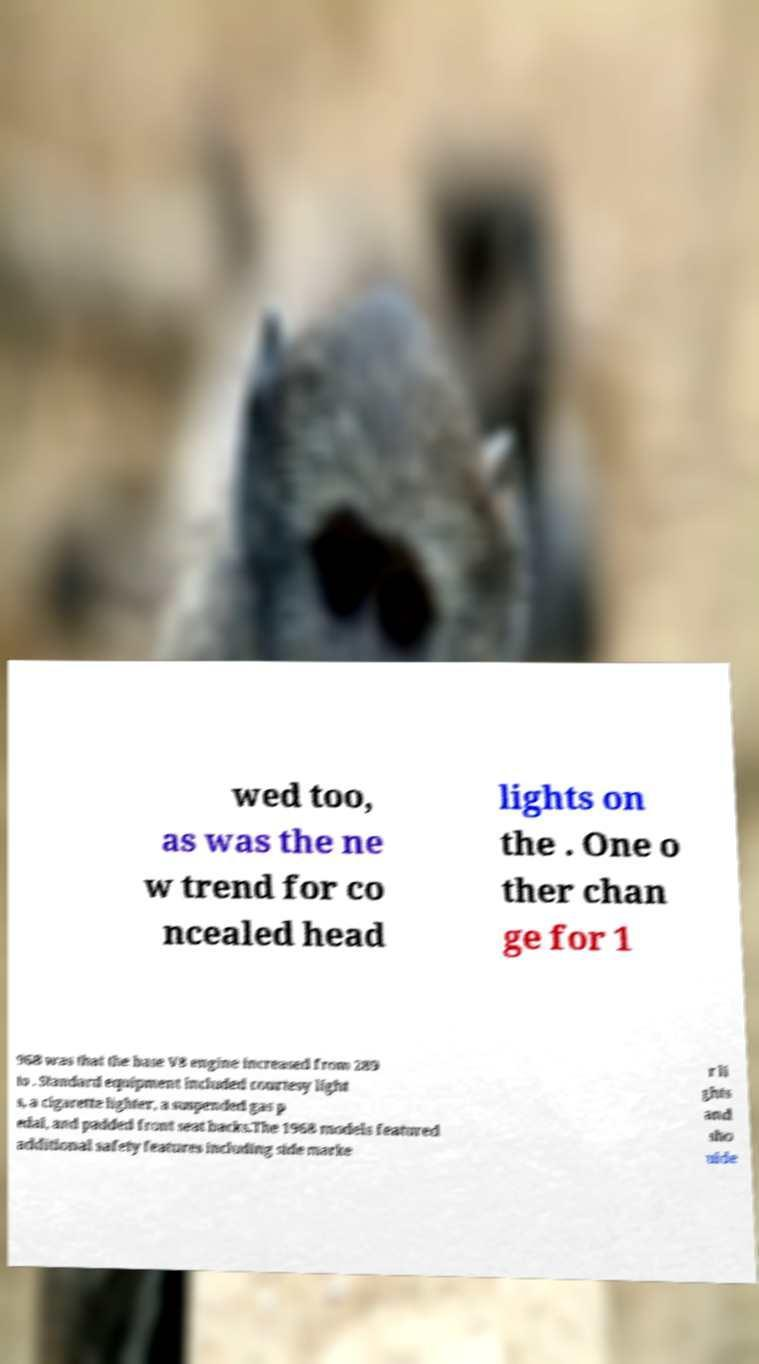Could you extract and type out the text from this image? wed too, as was the ne w trend for co ncealed head lights on the . One o ther chan ge for 1 968 was that the base V8 engine increased from 289 to . Standard equipment included courtesy light s, a cigarette lighter, a suspended gas p edal, and padded front seat backs.The 1968 models featured additional safety features including side marke r li ghts and sho ulde 